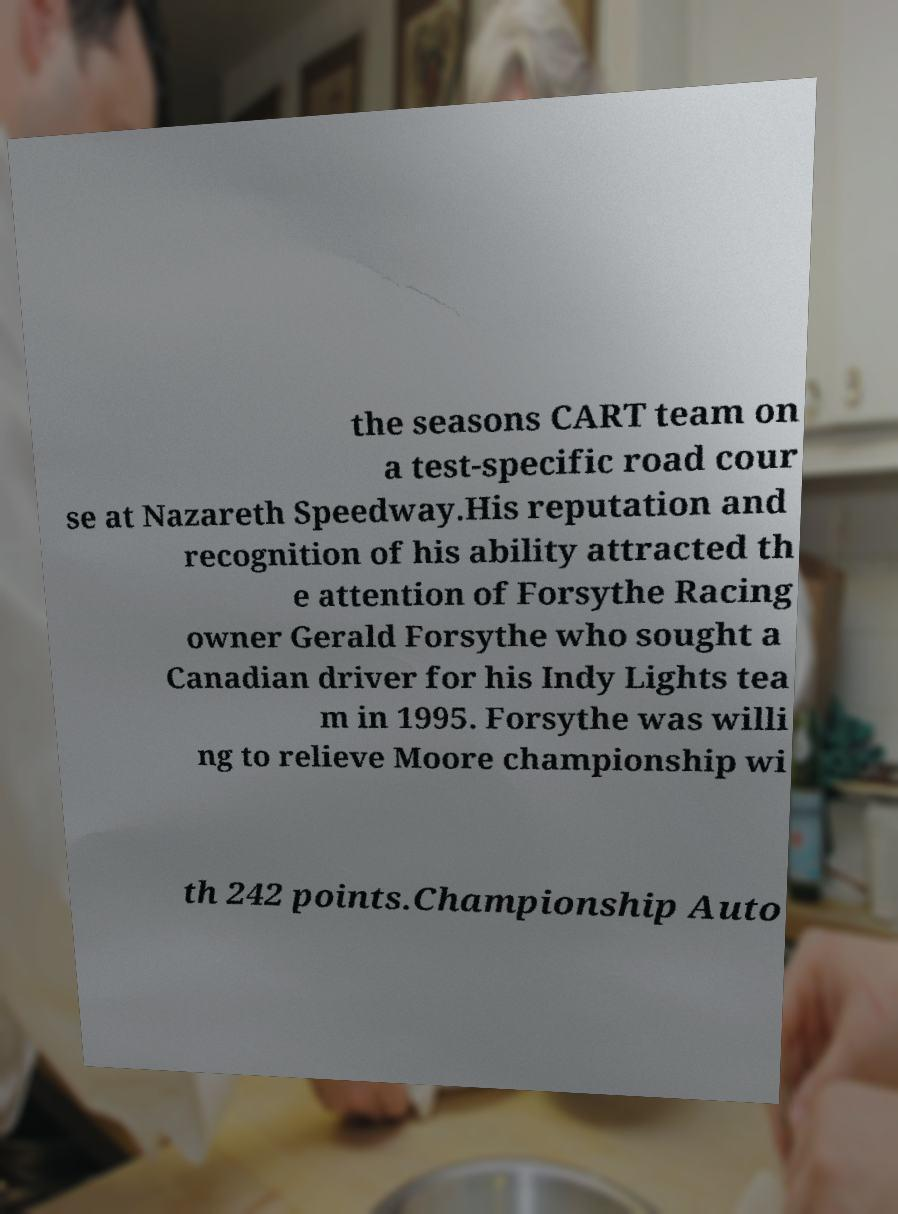I need the written content from this picture converted into text. Can you do that? the seasons CART team on a test-specific road cour se at Nazareth Speedway.His reputation and recognition of his ability attracted th e attention of Forsythe Racing owner Gerald Forsythe who sought a Canadian driver for his Indy Lights tea m in 1995. Forsythe was willi ng to relieve Moore championship wi th 242 points.Championship Auto 